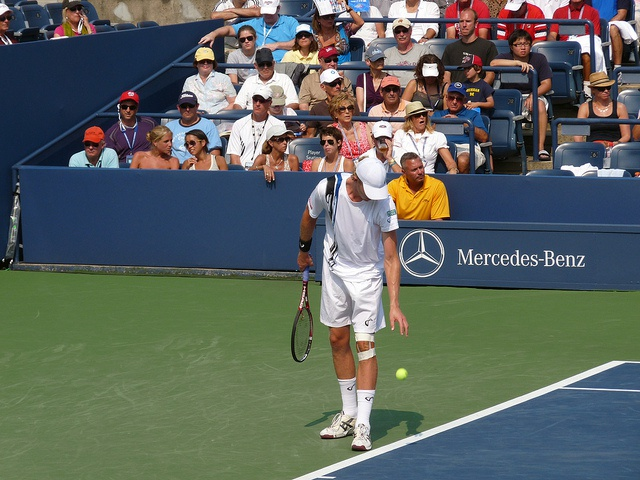Describe the objects in this image and their specific colors. I can see people in blue, black, navy, white, and gray tones, people in gray, lightgray, darkgray, and salmon tones, people in gray, orange, red, and maroon tones, people in gray, white, brown, black, and darkgray tones, and people in gray, white, maroon, darkgray, and brown tones in this image. 